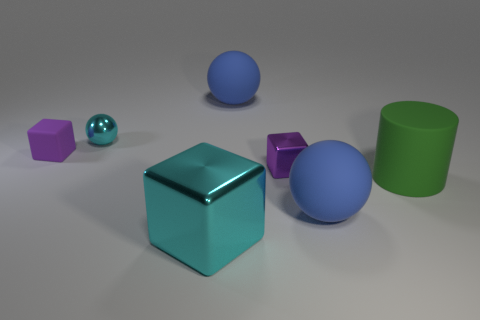Subtract all shiny cubes. How many cubes are left? 1 Add 3 big cubes. How many objects exist? 10 Subtract all cyan cubes. How many cubes are left? 2 Subtract 0 red cubes. How many objects are left? 7 Subtract all cylinders. How many objects are left? 6 Subtract all blue spheres. Subtract all cyan cylinders. How many spheres are left? 1 Subtract all blue cylinders. How many yellow cubes are left? 0 Subtract all metallic things. Subtract all small rubber things. How many objects are left? 3 Add 7 small metal blocks. How many small metal blocks are left? 8 Add 4 cylinders. How many cylinders exist? 5 